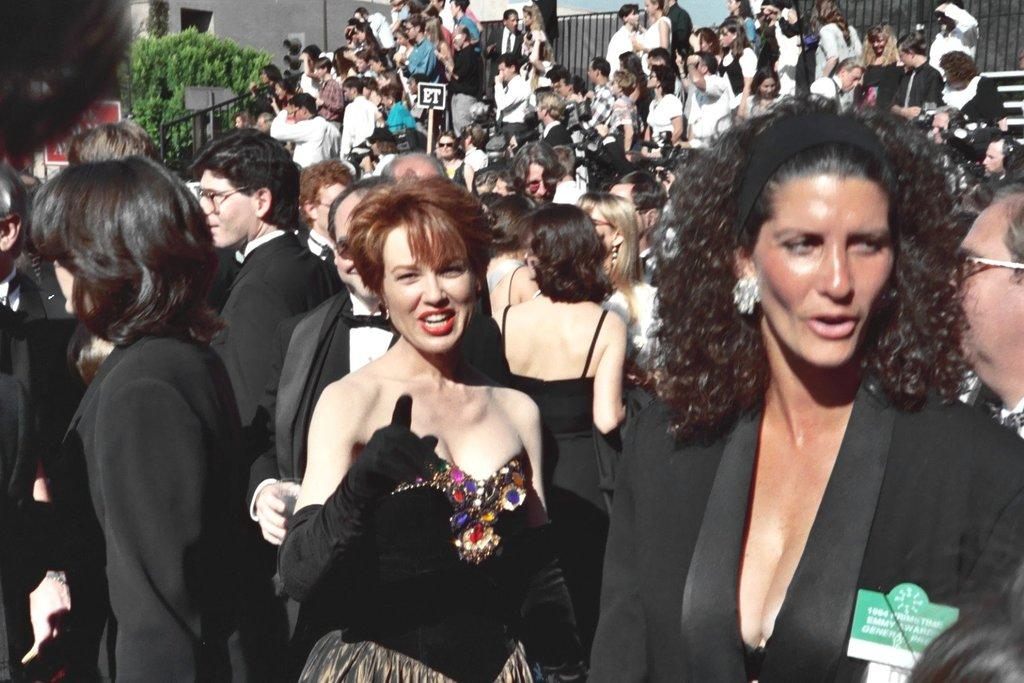What type of living organisms can be seen in the image? Plants can be seen in the image. What architectural feature is present in the image? There is a railing in the image. What type of barrier can be seen in the image? There is a fence in the image. Who or what is present in the image? There are people in the image. What type of sock is being used to cause a reaction in the image? There is no sock present in the image, and no reaction is being caused. How much zinc can be seen in the image? There is no zinc present in the image. 